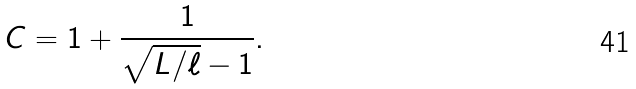Convert formula to latex. <formula><loc_0><loc_0><loc_500><loc_500>C = 1 + \frac { 1 } { \sqrt { L / \ell } - 1 } .</formula> 